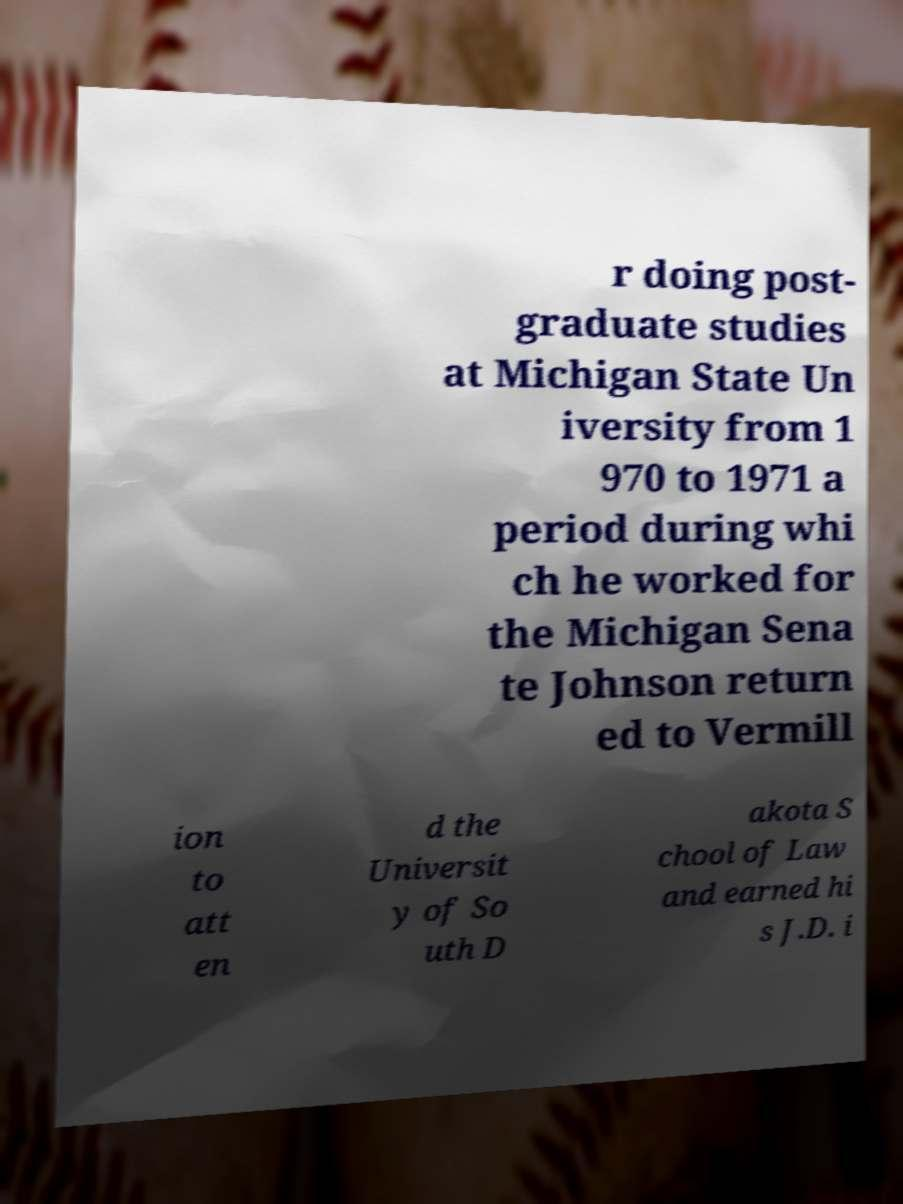Please read and relay the text visible in this image. What does it say? r doing post- graduate studies at Michigan State Un iversity from 1 970 to 1971 a period during whi ch he worked for the Michigan Sena te Johnson return ed to Vermill ion to att en d the Universit y of So uth D akota S chool of Law and earned hi s J.D. i 